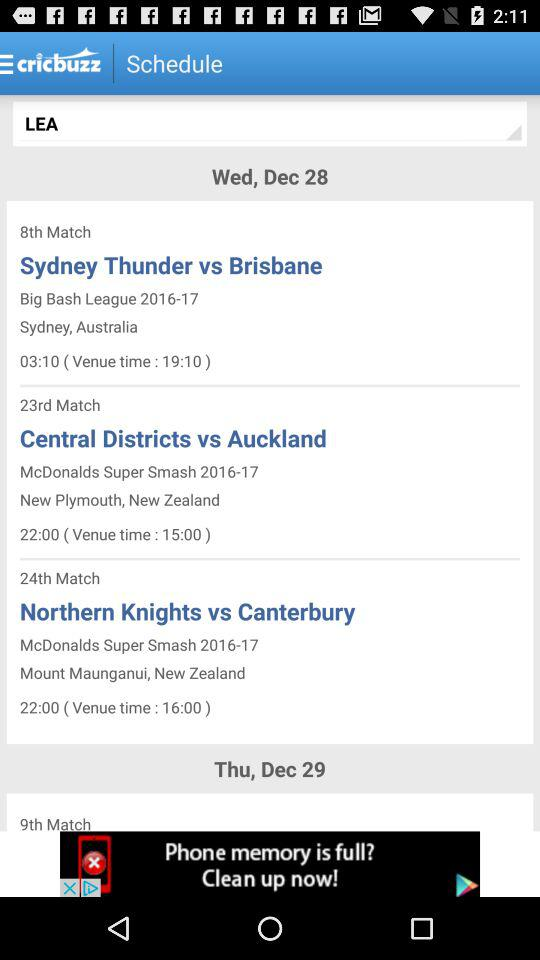How many non-English language options are available?
Answer the question using a single word or phrase. 6 